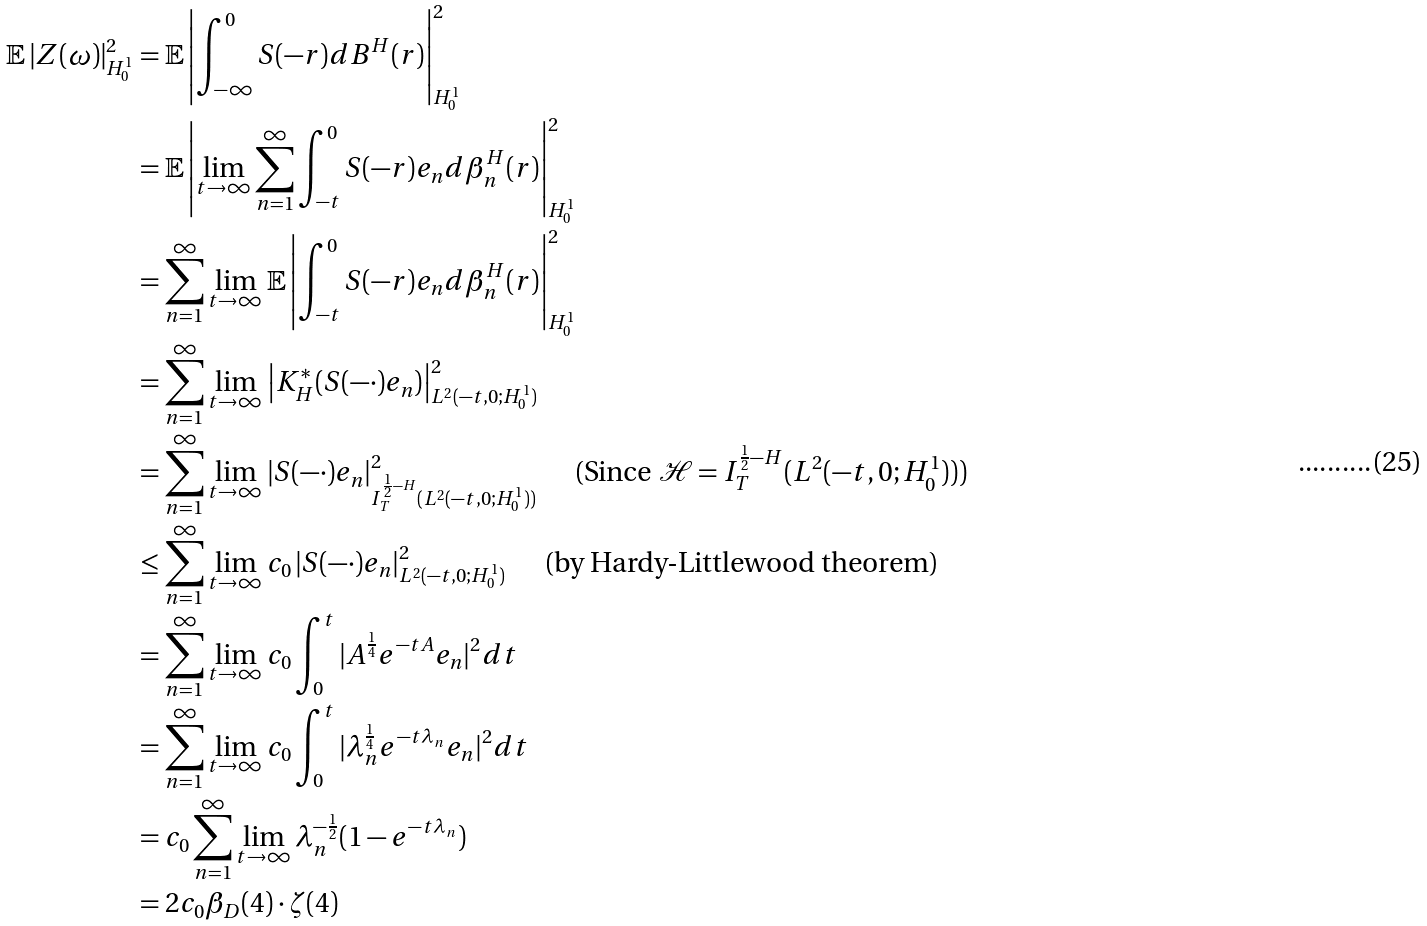<formula> <loc_0><loc_0><loc_500><loc_500>\mathbb { E } \left | Z ( \omega ) \right | _ { H _ { 0 } ^ { 1 } } ^ { 2 } & = \mathbb { E } \left | \int _ { - \infty } ^ { 0 } S ( - r ) d B ^ { H } ( r ) \right | _ { H _ { 0 } ^ { 1 } } ^ { 2 } \\ & = \mathbb { E } \left | \lim _ { t \rightarrow \infty } \sum _ { n = 1 } ^ { \infty } \int _ { - t } ^ { 0 } S ( - r ) e _ { n } d \beta _ { n } ^ { H } ( r ) \right | _ { H _ { 0 } ^ { 1 } } ^ { 2 } \\ & = \sum _ { n = 1 } ^ { \infty } \lim _ { t \rightarrow \infty } \mathbb { E } \left | \int _ { - t } ^ { 0 } S ( - r ) e _ { n } d \beta _ { n } ^ { H } ( r ) \right | _ { H _ { 0 } ^ { 1 } } ^ { 2 } \\ & = \sum _ { n = 1 } ^ { \infty } \lim _ { t \rightarrow \infty } \left | K ^ { * } _ { H } ( S ( - \cdot ) e _ { n } ) \right | _ { L ^ { 2 } ( - t , 0 ; H _ { 0 } ^ { 1 } ) } ^ { 2 } \\ & = \sum _ { n = 1 } ^ { \infty } \lim _ { t \rightarrow \infty } \left | S ( - \cdot ) e _ { n } \right | _ { I _ { T } ^ { \frac { 1 } { 2 } - H } ( L ^ { 2 } ( - t , 0 ; H _ { 0 } ^ { 1 } ) ) } ^ { 2 } \quad \text { (Since } \mathcal { H } = I _ { T } ^ { \frac { 1 } { 2 } - H } ( L ^ { 2 } ( - t , 0 ; H _ { 0 } ^ { 1 } ) ) ) \\ & \leq \sum _ { n = 1 } ^ { \infty } \lim _ { t \rightarrow \infty } c _ { 0 } \left | S ( - \cdot ) e _ { n } \right | _ { L ^ { 2 } ( - t , 0 ; H _ { 0 } ^ { 1 } ) } ^ { 2 } \quad \text { (by Hardy-Littlewood theorem)} \\ & = \sum _ { n = 1 } ^ { \infty } \lim _ { t \rightarrow \infty } c _ { 0 } \int _ { 0 } ^ { t } | A ^ { \frac { 1 } { 4 } } e ^ { - t A } e _ { n } | ^ { 2 } d t \\ & = \sum _ { n = 1 } ^ { \infty } \lim _ { t \rightarrow \infty } c _ { 0 } \int _ { 0 } ^ { t } | \lambda _ { n } ^ { \frac { 1 } { 4 } } e ^ { - t \lambda _ { n } } e _ { n } | ^ { 2 } d t \\ & = c _ { 0 } \sum _ { n = 1 } ^ { \infty } \lim _ { t \rightarrow \infty } \lambda _ { n } ^ { - \frac { 1 } { 2 } } ( 1 - e ^ { - t \lambda _ { n } } ) \\ & = 2 c _ { 0 } \beta _ { D } ( 4 ) \cdot \zeta ( 4 )</formula> 